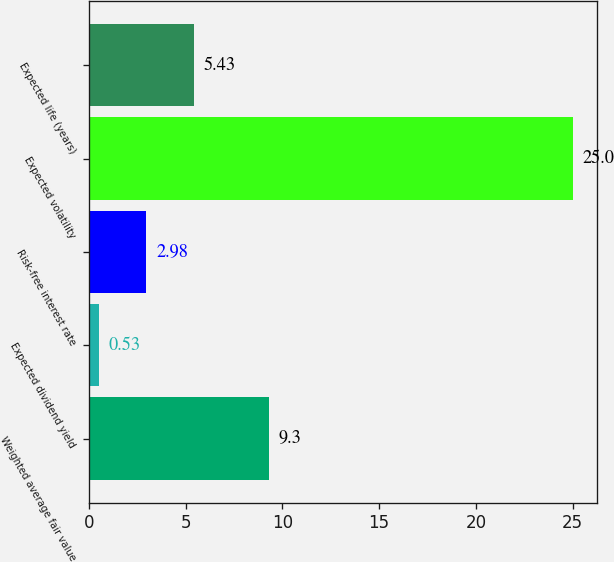<chart> <loc_0><loc_0><loc_500><loc_500><bar_chart><fcel>Weighted average fair value<fcel>Expected dividend yield<fcel>Risk-free interest rate<fcel>Expected volatility<fcel>Expected life (years)<nl><fcel>9.3<fcel>0.53<fcel>2.98<fcel>25<fcel>5.43<nl></chart> 